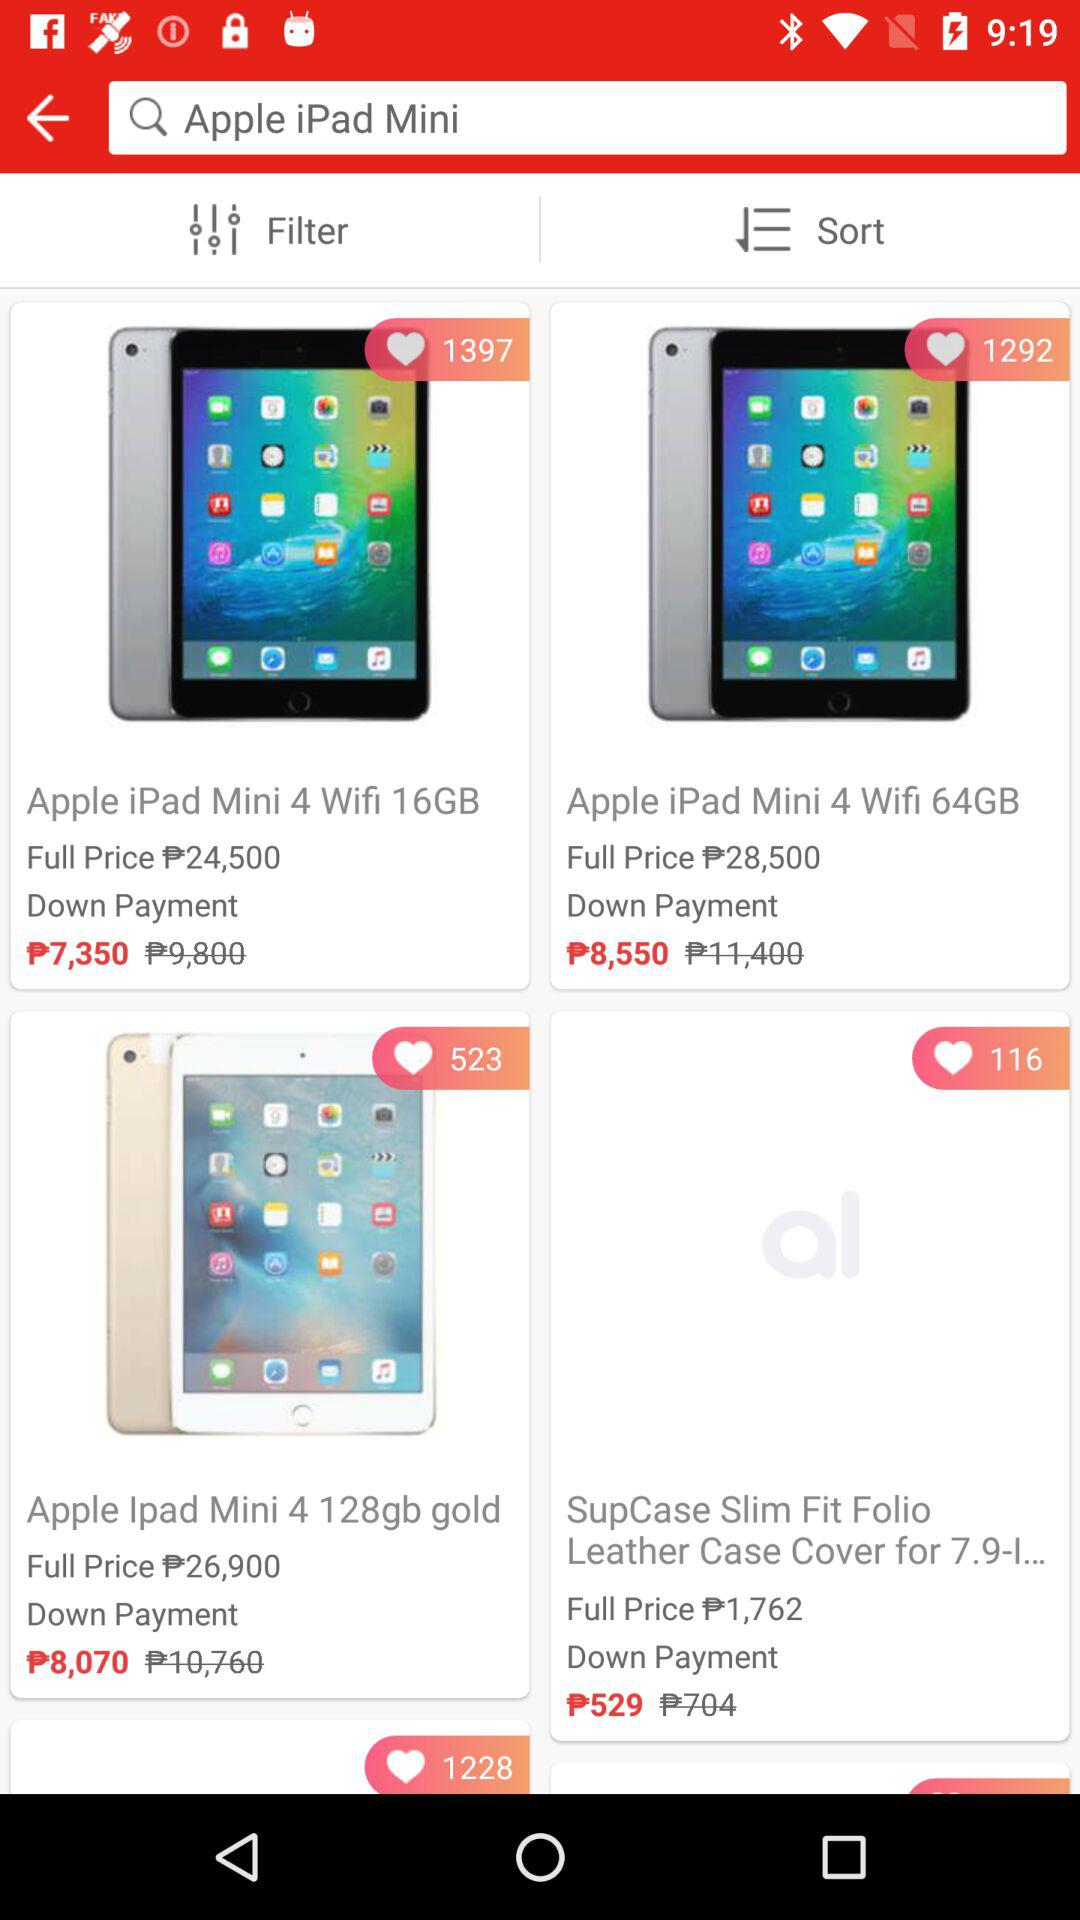How many likes has the "Apple iPad Mini 4 Wifi 16GB" received? The "Apple iPad Mini 4 Wifi 16GB" has received 1397 likes. 